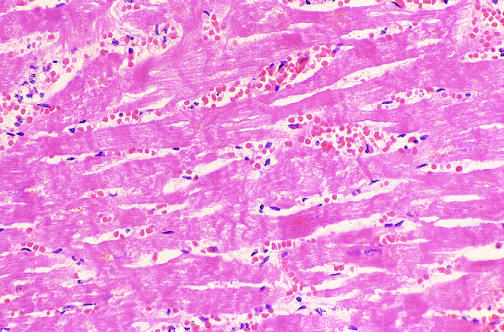what are seen microscopically?
Answer the question using a single word or phrase. Hemorrhage and contraction bands 